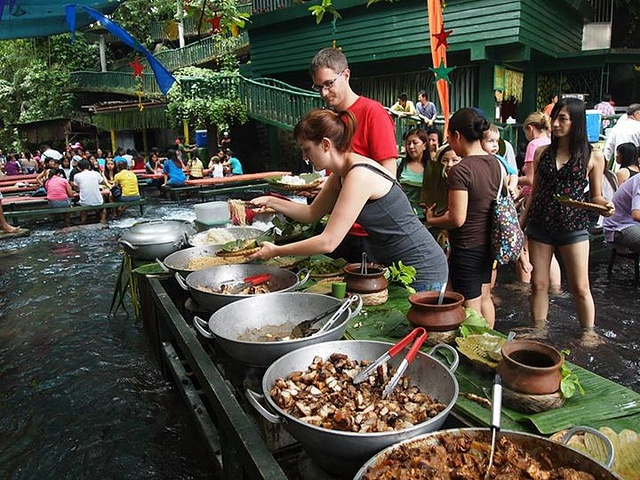Describe the objects in this image and their specific colors. I can see dining table in navy, black, gray, darkgray, and maroon tones, people in navy, black, white, gray, and darkgray tones, people in navy, black, gray, maroon, and tan tones, people in navy, black, maroon, and gray tones, and people in navy, black, maroon, brown, and tan tones in this image. 